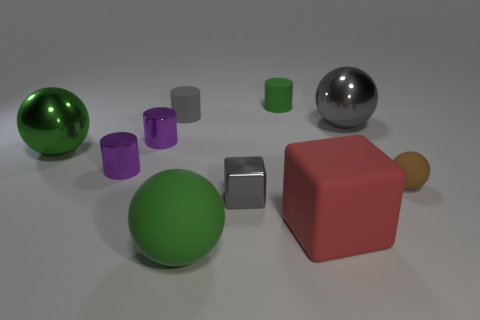Subtract all tiny green cylinders. How many cylinders are left? 3 Subtract all gray cubes. How many cubes are left? 1 Subtract all cylinders. How many objects are left? 6 Subtract 4 spheres. How many spheres are left? 0 Subtract 1 red blocks. How many objects are left? 9 Subtract all green blocks. Subtract all purple balls. How many blocks are left? 2 Subtract all purple cylinders. How many brown balls are left? 1 Subtract all big red objects. Subtract all brown spheres. How many objects are left? 8 Add 7 brown matte objects. How many brown matte objects are left? 8 Add 5 big green metallic objects. How many big green metallic objects exist? 6 